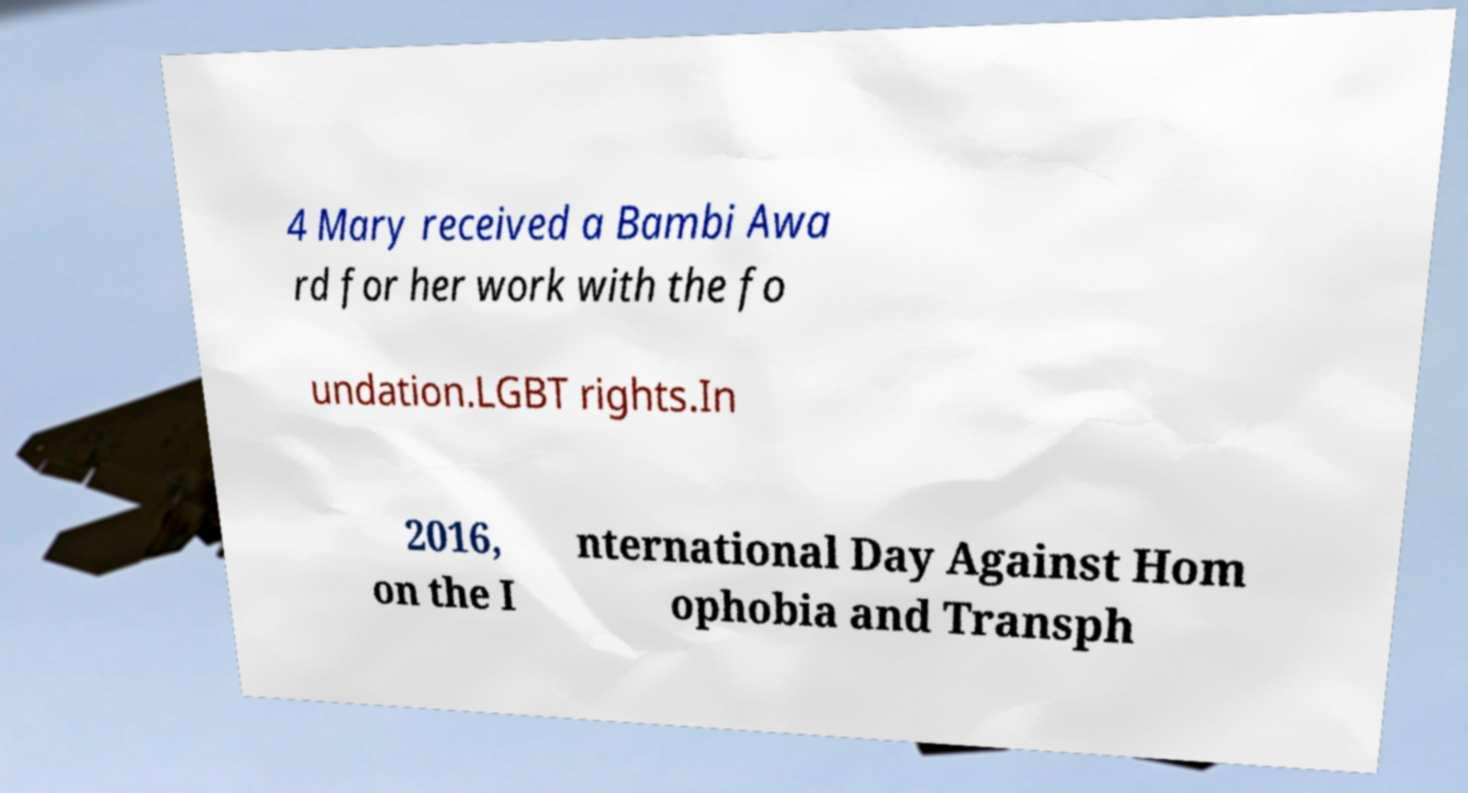Could you assist in decoding the text presented in this image and type it out clearly? 4 Mary received a Bambi Awa rd for her work with the fo undation.LGBT rights.In 2016, on the I nternational Day Against Hom ophobia and Transph 